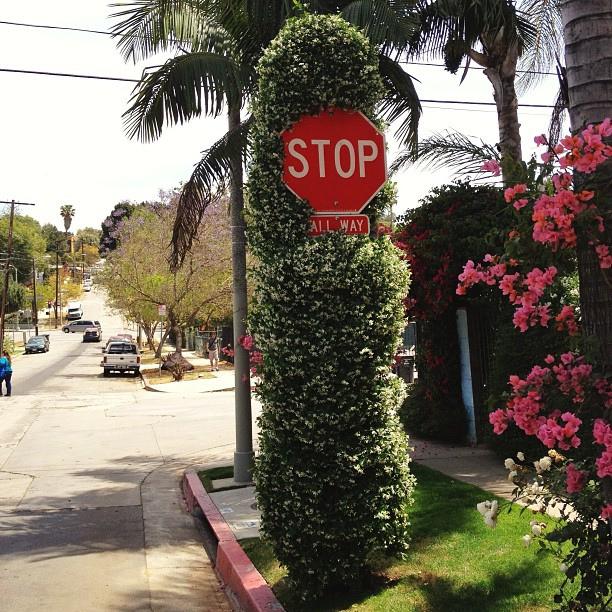Is this sign visible to most drivers on the road?
Give a very brief answer. Yes. Is there a palm tree?
Answer briefly. Yes. What type of flower can be seen in the front?
Quick response, please. Pink flowers. 